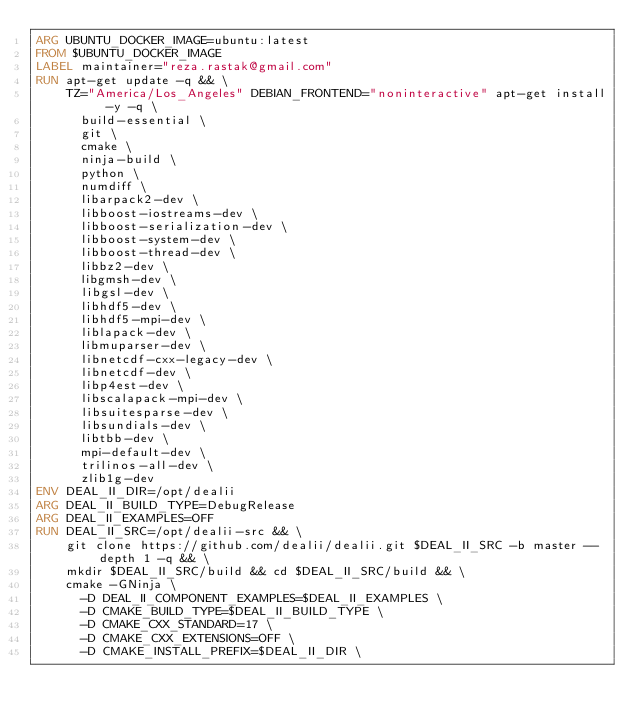<code> <loc_0><loc_0><loc_500><loc_500><_Dockerfile_>ARG UBUNTU_DOCKER_IMAGE=ubuntu:latest
FROM $UBUNTU_DOCKER_IMAGE
LABEL maintainer="reza.rastak@gmail.com"
RUN apt-get update -q && \
    TZ="America/Los_Angeles" DEBIAN_FRONTEND="noninteractive" apt-get install -y -q \
      build-essential \
      git \
      cmake \
      ninja-build \
      python \
      numdiff \
      libarpack2-dev \
      libboost-iostreams-dev \
      libboost-serialization-dev \
      libboost-system-dev \
      libboost-thread-dev \
      libbz2-dev \
      libgmsh-dev \
      libgsl-dev \
      libhdf5-dev \
      libhdf5-mpi-dev \
      liblapack-dev \
      libmuparser-dev \
      libnetcdf-cxx-legacy-dev \
      libnetcdf-dev \
      libp4est-dev \
      libscalapack-mpi-dev \
      libsuitesparse-dev \
      libsundials-dev \
      libtbb-dev \
      mpi-default-dev \
      trilinos-all-dev \
      zlib1g-dev
ENV DEAL_II_DIR=/opt/dealii
ARG DEAL_II_BUILD_TYPE=DebugRelease
ARG DEAL_II_EXAMPLES=OFF
RUN DEAL_II_SRC=/opt/dealii-src && \
    git clone https://github.com/dealii/dealii.git $DEAL_II_SRC -b master --depth 1 -q && \
    mkdir $DEAL_II_SRC/build && cd $DEAL_II_SRC/build && \
    cmake -GNinja \
      -D DEAL_II_COMPONENT_EXAMPLES=$DEAL_II_EXAMPLES \
      -D CMAKE_BUILD_TYPE=$DEAL_II_BUILD_TYPE \
      -D CMAKE_CXX_STANDARD=17 \
      -D CMAKE_CXX_EXTENSIONS=OFF \
      -D CMAKE_INSTALL_PREFIX=$DEAL_II_DIR \</code> 